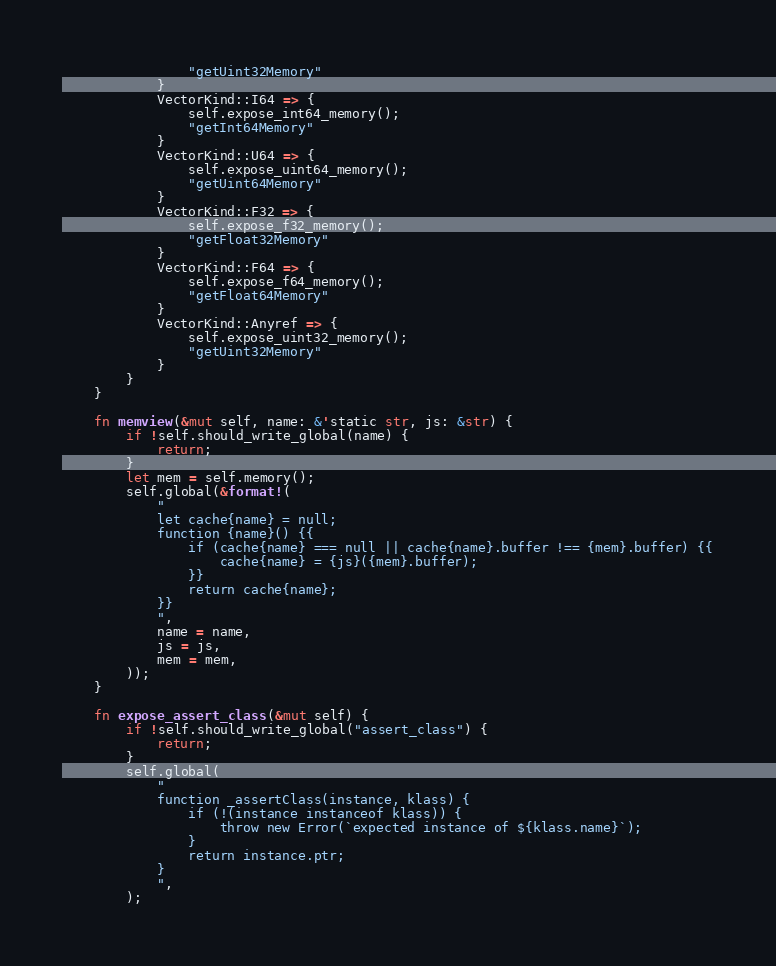<code> <loc_0><loc_0><loc_500><loc_500><_Rust_>                "getUint32Memory"
            }
            VectorKind::I64 => {
                self.expose_int64_memory();
                "getInt64Memory"
            }
            VectorKind::U64 => {
                self.expose_uint64_memory();
                "getUint64Memory"
            }
            VectorKind::F32 => {
                self.expose_f32_memory();
                "getFloat32Memory"
            }
            VectorKind::F64 => {
                self.expose_f64_memory();
                "getFloat64Memory"
            }
            VectorKind::Anyref => {
                self.expose_uint32_memory();
                "getUint32Memory"
            }
        }
    }

    fn memview(&mut self, name: &'static str, js: &str) {
        if !self.should_write_global(name) {
            return;
        }
        let mem = self.memory();
        self.global(&format!(
            "
            let cache{name} = null;
            function {name}() {{
                if (cache{name} === null || cache{name}.buffer !== {mem}.buffer) {{
                    cache{name} = {js}({mem}.buffer);
                }}
                return cache{name};
            }}
            ",
            name = name,
            js = js,
            mem = mem,
        ));
    }

    fn expose_assert_class(&mut self) {
        if !self.should_write_global("assert_class") {
            return;
        }
        self.global(
            "
            function _assertClass(instance, klass) {
                if (!(instance instanceof klass)) {
                    throw new Error(`expected instance of ${klass.name}`);
                }
                return instance.ptr;
            }
            ",
        );</code> 